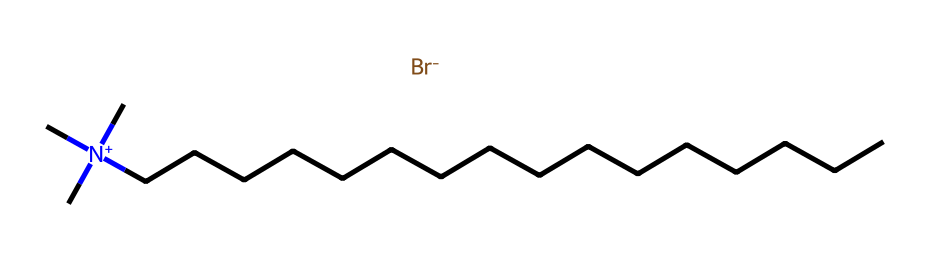What is the total number of carbon atoms in cetrimonium bromide? The SMILES representation shows a long hydrocarbon chain denoted by the "C" characters. Counting these, there are 16 carbon atoms (indicated by the 16 "C" in "CCCCCCCCCCCCCCCC").
Answer: 16 How many nitrogen atoms are present in the structure? In the SMILES, the nitrogen atom is represented by the "N" in "[N+](C)(C)C". There is only one nitrogen atom visible in this structure.
Answer: 1 What functional group is indicated by the "[Br-]" in the structure? The "[Br-]" notation indicates the presence of a bromide ion, which is a halogen functional group. Bromine implies a negatively charged species, making it a bromide group.
Answer: bromide What does the presence of the positively charged nitrogen suggest about this surfactant? The "N+" indicates that there is a quaternary ammonium group, which is characteristic of cationic surfactants, suggesting it has hydrophilic properties enhancing solubility in water.
Answer: cationic surfactant How many hydrophobic carbon chains are there in this surfactant? The long chain of carbon atoms (16 C's) constitutes a single hydrophobic portion of the molecule. Thus, there is one hydrophobic chain which is the fatty tail.
Answer: 1 What role does cetrimonium bromide play in luxury hair conditioners? As a surfactant, cetrimonium bromide primarily functions to reduce surface tension, aiding in wetting and allowing for better spreading on hair surfaces, providing conditioning properties.
Answer: conditioning agent 